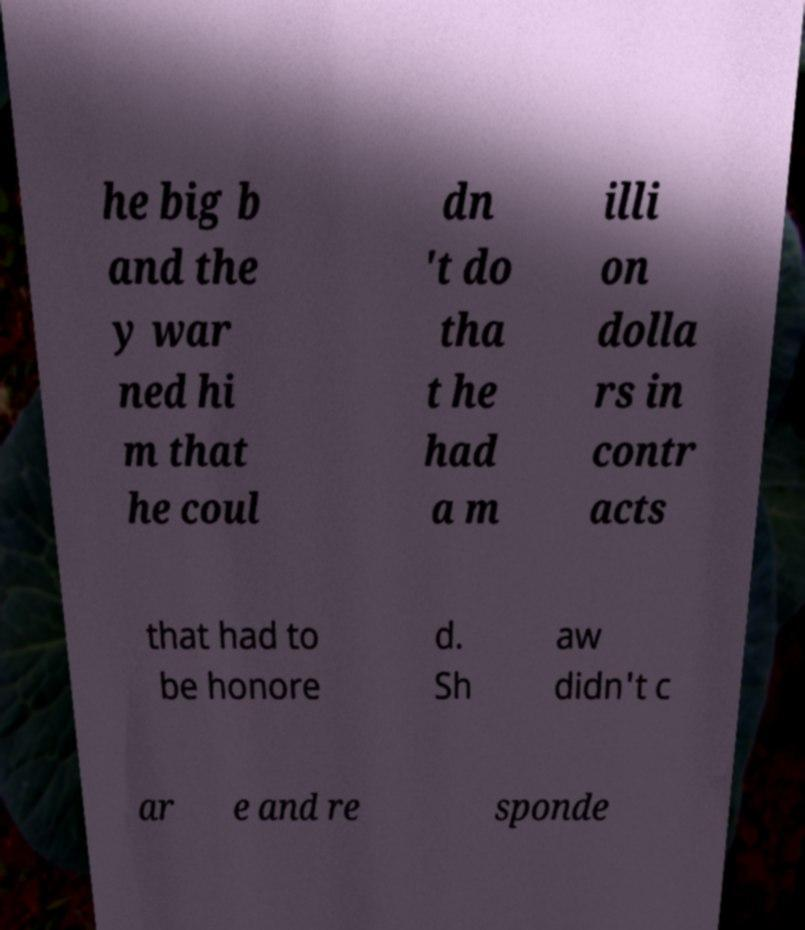There's text embedded in this image that I need extracted. Can you transcribe it verbatim? he big b and the y war ned hi m that he coul dn 't do tha t he had a m illi on dolla rs in contr acts that had to be honore d. Sh aw didn't c ar e and re sponde 